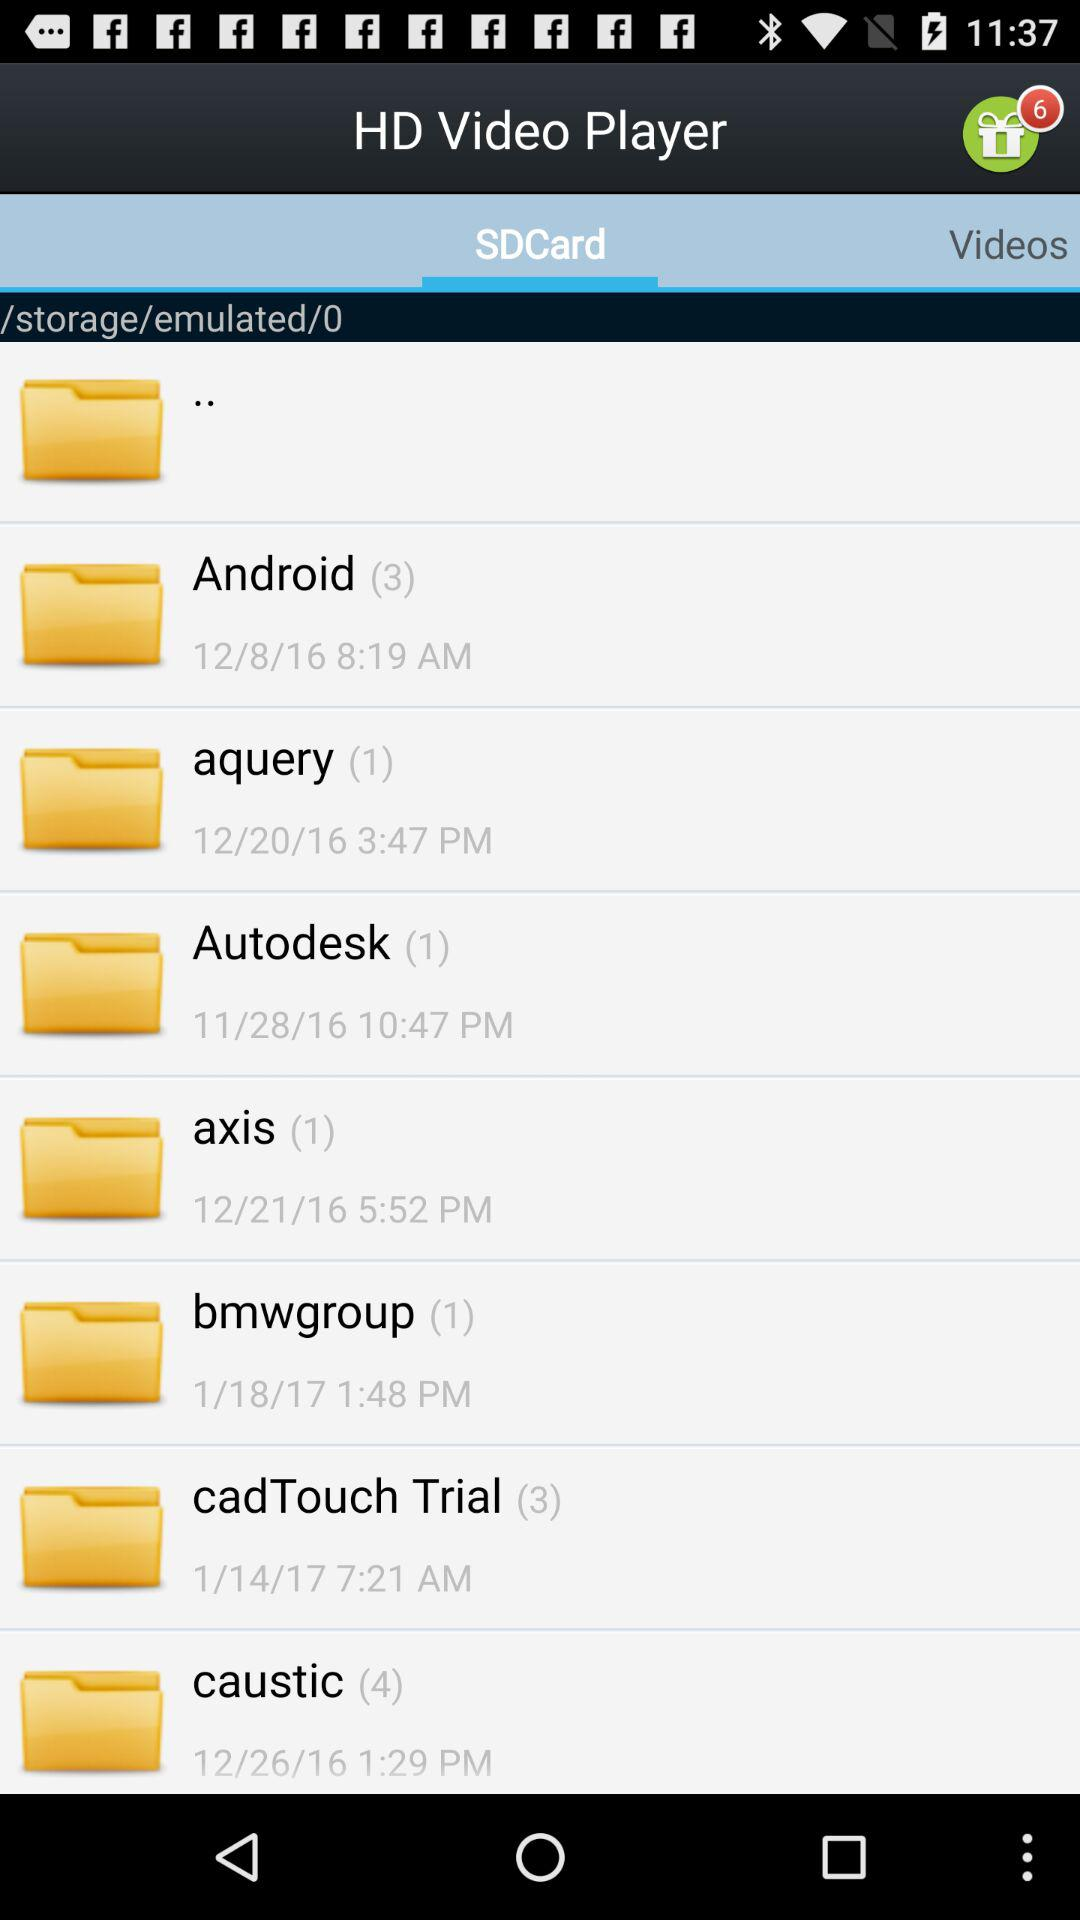What is the time of the "axis" album? The time of the "axis" album is 5:52 PM. 